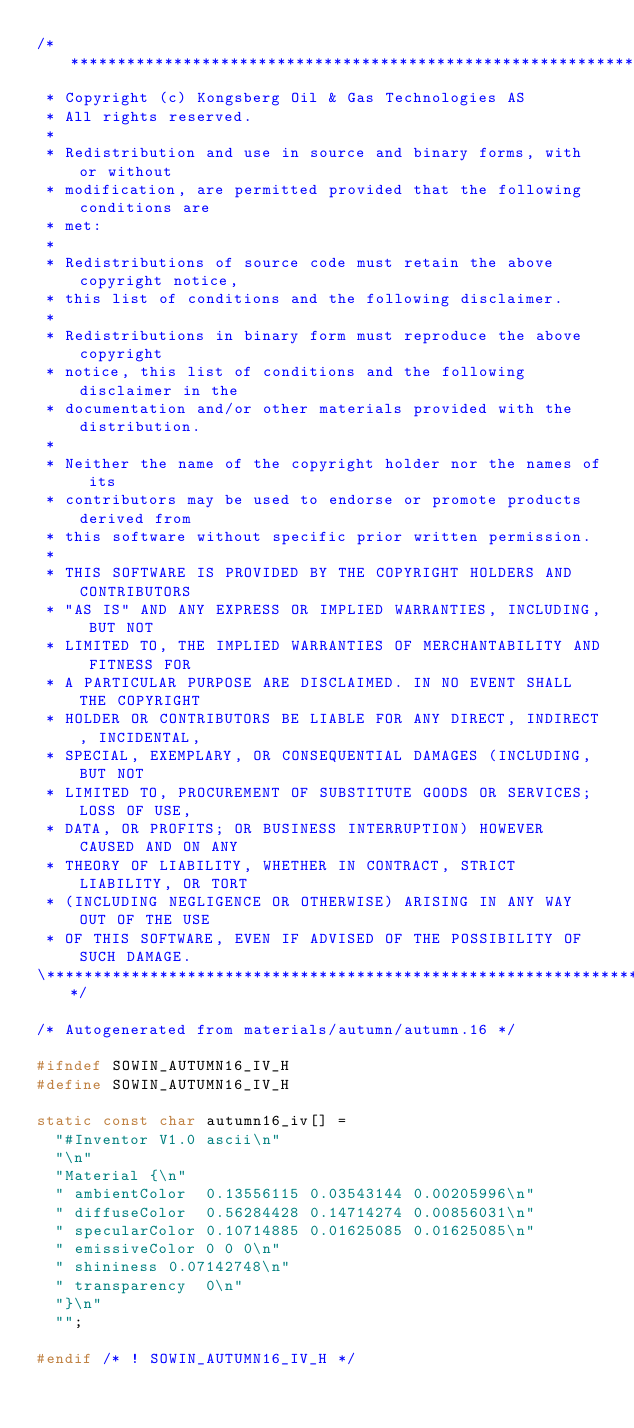<code> <loc_0><loc_0><loc_500><loc_500><_C_>/**************************************************************************\
 * Copyright (c) Kongsberg Oil & Gas Technologies AS
 * All rights reserved.
 * 
 * Redistribution and use in source and binary forms, with or without
 * modification, are permitted provided that the following conditions are
 * met:
 * 
 * Redistributions of source code must retain the above copyright notice,
 * this list of conditions and the following disclaimer.
 * 
 * Redistributions in binary form must reproduce the above copyright
 * notice, this list of conditions and the following disclaimer in the
 * documentation and/or other materials provided with the distribution.
 * 
 * Neither the name of the copyright holder nor the names of its
 * contributors may be used to endorse or promote products derived from
 * this software without specific prior written permission.
 * 
 * THIS SOFTWARE IS PROVIDED BY THE COPYRIGHT HOLDERS AND CONTRIBUTORS
 * "AS IS" AND ANY EXPRESS OR IMPLIED WARRANTIES, INCLUDING, BUT NOT
 * LIMITED TO, THE IMPLIED WARRANTIES OF MERCHANTABILITY AND FITNESS FOR
 * A PARTICULAR PURPOSE ARE DISCLAIMED. IN NO EVENT SHALL THE COPYRIGHT
 * HOLDER OR CONTRIBUTORS BE LIABLE FOR ANY DIRECT, INDIRECT, INCIDENTAL,
 * SPECIAL, EXEMPLARY, OR CONSEQUENTIAL DAMAGES (INCLUDING, BUT NOT
 * LIMITED TO, PROCUREMENT OF SUBSTITUTE GOODS OR SERVICES; LOSS OF USE,
 * DATA, OR PROFITS; OR BUSINESS INTERRUPTION) HOWEVER CAUSED AND ON ANY
 * THEORY OF LIABILITY, WHETHER IN CONTRACT, STRICT LIABILITY, OR TORT
 * (INCLUDING NEGLIGENCE OR OTHERWISE) ARISING IN ANY WAY OUT OF THE USE
 * OF THIS SOFTWARE, EVEN IF ADVISED OF THE POSSIBILITY OF SUCH DAMAGE.
\**************************************************************************/

/* Autogenerated from materials/autumn/autumn.16 */

#ifndef SOWIN_AUTUMN16_IV_H
#define SOWIN_AUTUMN16_IV_H

static const char autumn16_iv[] =
  "#Inventor V1.0 ascii\n"
  "\n"
  "Material {\n"
  "	ambientColor	0.13556115 0.03543144 0.00205996\n"
  "	diffuseColor	0.56284428 0.14714274 0.00856031\n"
  "	specularColor	0.10714885 0.01625085 0.01625085\n"
  "	emissiveColor	0 0 0\n"
  "	shininess	0.07142748\n"
  "	transparency	0\n"
  "}\n"
  "";

#endif /* ! SOWIN_AUTUMN16_IV_H */
</code> 